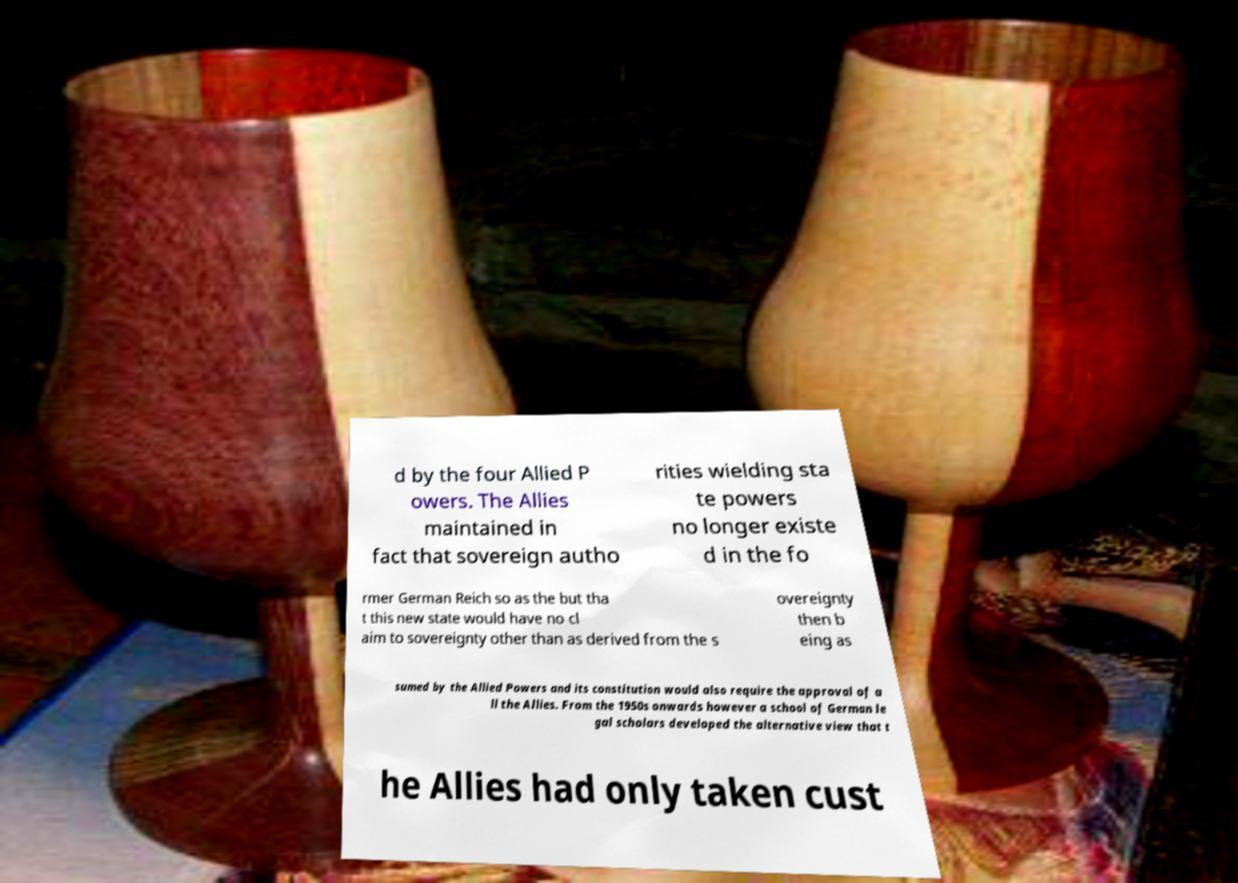Could you assist in decoding the text presented in this image and type it out clearly? d by the four Allied P owers. The Allies maintained in fact that sovereign autho rities wielding sta te powers no longer existe d in the fo rmer German Reich so as the but tha t this new state would have no cl aim to sovereignty other than as derived from the s overeignty then b eing as sumed by the Allied Powers and its constitution would also require the approval of a ll the Allies. From the 1950s onwards however a school of German le gal scholars developed the alternative view that t he Allies had only taken cust 